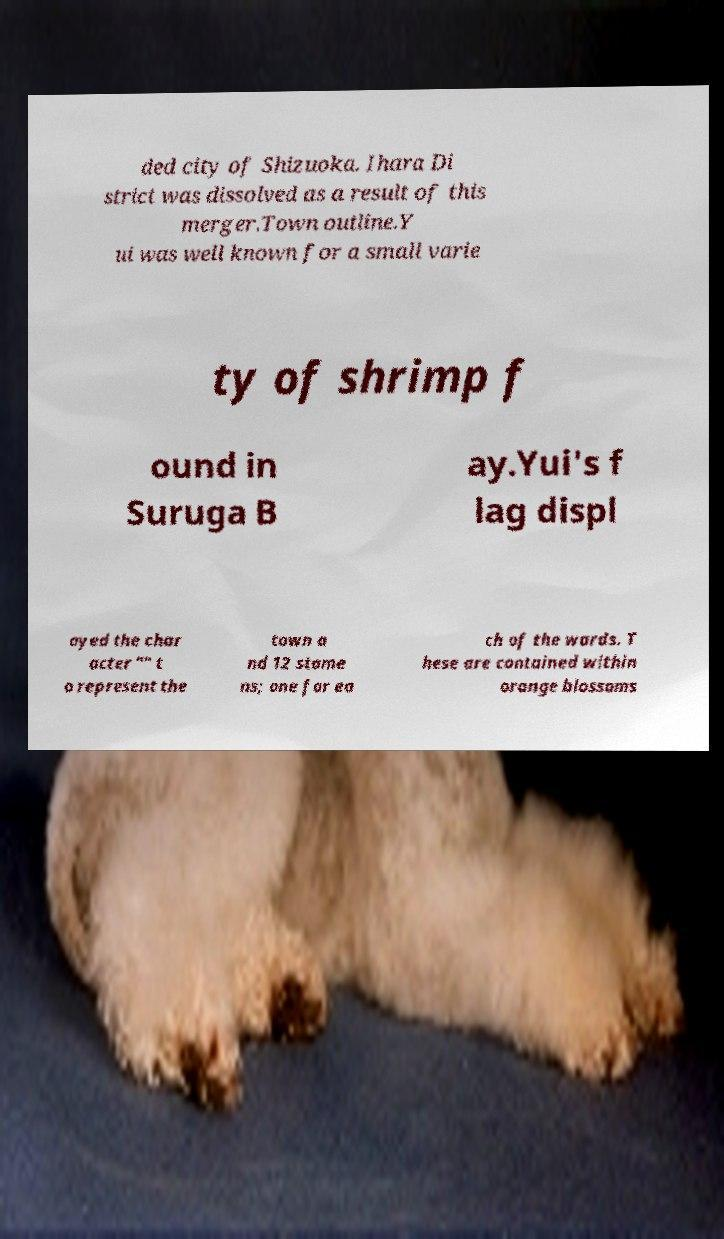Can you accurately transcribe the text from the provided image for me? ded city of Shizuoka. Ihara Di strict was dissolved as a result of this merger.Town outline.Y ui was well known for a small varie ty of shrimp f ound in Suruga B ay.Yui's f lag displ ayed the char acter "" t o represent the town a nd 12 stame ns; one for ea ch of the wards. T hese are contained within orange blossoms 